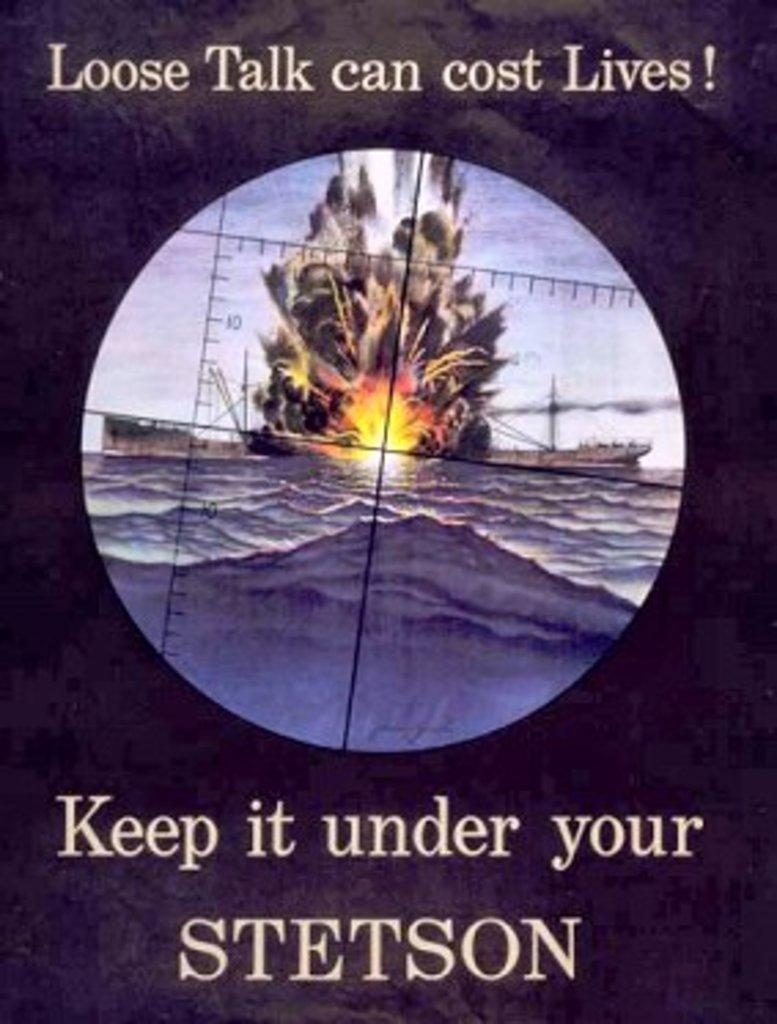Provide a one-sentence caption for the provided image. poster showing a ship getting bombed and words at top loose talk can cost lives. 